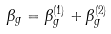<formula> <loc_0><loc_0><loc_500><loc_500>\beta _ { g } = \beta _ { g } ^ { ( 1 ) } + \beta _ { g } ^ { ( 2 ) }</formula> 